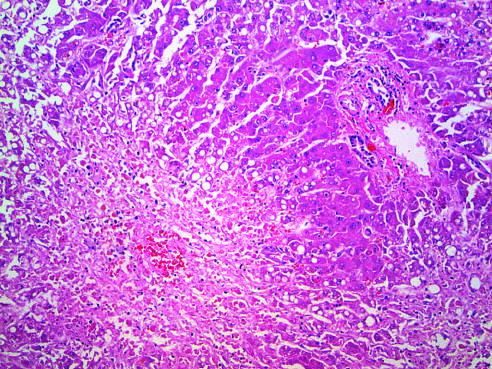s confluent necrosis seen in the perivenular region zone 3?
Answer the question using a single word or phrase. Yes 